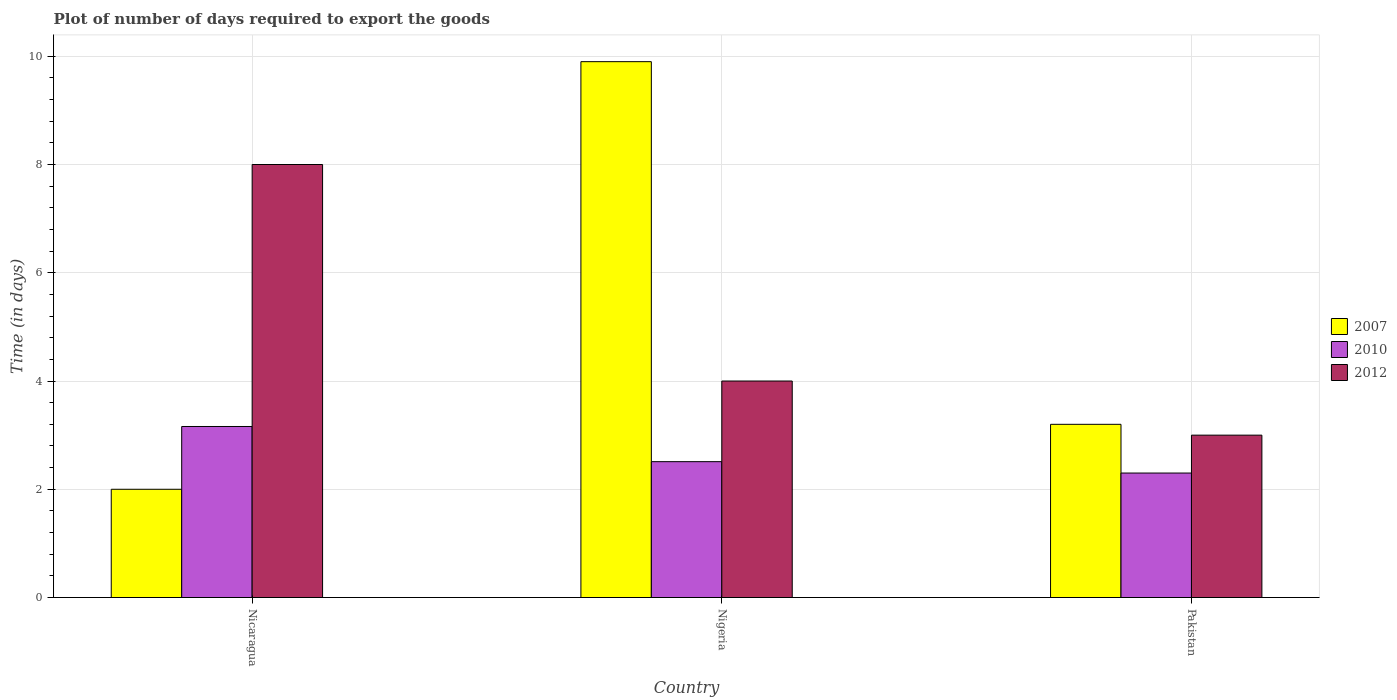Are the number of bars per tick equal to the number of legend labels?
Your response must be concise. Yes. How many bars are there on the 2nd tick from the left?
Keep it short and to the point. 3. What is the time required to export goods in 2010 in Pakistan?
Provide a succinct answer. 2.3. In which country was the time required to export goods in 2007 maximum?
Offer a terse response. Nigeria. What is the difference between the time required to export goods in 2010 in Nigeria and that in Pakistan?
Offer a very short reply. 0.21. What is the difference between the time required to export goods in 2012 in Nigeria and the time required to export goods in 2010 in Nicaragua?
Provide a succinct answer. 0.84. In how many countries, is the time required to export goods in 2012 greater than 7.6 days?
Provide a short and direct response. 1. Is the time required to export goods in 2012 in Nicaragua less than that in Pakistan?
Give a very brief answer. No. In how many countries, is the time required to export goods in 2010 greater than the average time required to export goods in 2010 taken over all countries?
Your answer should be very brief. 1. What does the 3rd bar from the left in Pakistan represents?
Your answer should be very brief. 2012. How many bars are there?
Your answer should be compact. 9. Are all the bars in the graph horizontal?
Give a very brief answer. No. Are the values on the major ticks of Y-axis written in scientific E-notation?
Your answer should be compact. No. Where does the legend appear in the graph?
Give a very brief answer. Center right. How many legend labels are there?
Offer a very short reply. 3. What is the title of the graph?
Ensure brevity in your answer.  Plot of number of days required to export the goods. Does "1985" appear as one of the legend labels in the graph?
Your answer should be very brief. No. What is the label or title of the Y-axis?
Ensure brevity in your answer.  Time (in days). What is the Time (in days) of 2010 in Nicaragua?
Your answer should be compact. 3.16. What is the Time (in days) in 2007 in Nigeria?
Offer a very short reply. 9.9. What is the Time (in days) in 2010 in Nigeria?
Ensure brevity in your answer.  2.51. What is the Time (in days) in 2012 in Nigeria?
Make the answer very short. 4. What is the Time (in days) in 2007 in Pakistan?
Provide a short and direct response. 3.2. What is the Time (in days) in 2010 in Pakistan?
Make the answer very short. 2.3. Across all countries, what is the maximum Time (in days) of 2010?
Your response must be concise. 3.16. Across all countries, what is the maximum Time (in days) of 2012?
Offer a terse response. 8. Across all countries, what is the minimum Time (in days) in 2010?
Make the answer very short. 2.3. What is the total Time (in days) in 2007 in the graph?
Your answer should be very brief. 15.1. What is the total Time (in days) of 2010 in the graph?
Offer a terse response. 7.97. What is the total Time (in days) of 2012 in the graph?
Your answer should be very brief. 15. What is the difference between the Time (in days) in 2010 in Nicaragua and that in Nigeria?
Offer a very short reply. 0.65. What is the difference between the Time (in days) in 2012 in Nicaragua and that in Nigeria?
Provide a short and direct response. 4. What is the difference between the Time (in days) in 2010 in Nicaragua and that in Pakistan?
Your answer should be very brief. 0.86. What is the difference between the Time (in days) of 2007 in Nigeria and that in Pakistan?
Offer a very short reply. 6.7. What is the difference between the Time (in days) in 2010 in Nigeria and that in Pakistan?
Keep it short and to the point. 0.21. What is the difference between the Time (in days) in 2012 in Nigeria and that in Pakistan?
Offer a very short reply. 1. What is the difference between the Time (in days) of 2007 in Nicaragua and the Time (in days) of 2010 in Nigeria?
Give a very brief answer. -0.51. What is the difference between the Time (in days) of 2007 in Nicaragua and the Time (in days) of 2012 in Nigeria?
Offer a very short reply. -2. What is the difference between the Time (in days) in 2010 in Nicaragua and the Time (in days) in 2012 in Nigeria?
Offer a very short reply. -0.84. What is the difference between the Time (in days) of 2007 in Nicaragua and the Time (in days) of 2010 in Pakistan?
Provide a succinct answer. -0.3. What is the difference between the Time (in days) in 2007 in Nicaragua and the Time (in days) in 2012 in Pakistan?
Make the answer very short. -1. What is the difference between the Time (in days) of 2010 in Nicaragua and the Time (in days) of 2012 in Pakistan?
Provide a succinct answer. 0.16. What is the difference between the Time (in days) in 2010 in Nigeria and the Time (in days) in 2012 in Pakistan?
Your response must be concise. -0.49. What is the average Time (in days) of 2007 per country?
Your answer should be very brief. 5.03. What is the average Time (in days) of 2010 per country?
Give a very brief answer. 2.66. What is the average Time (in days) of 2012 per country?
Your answer should be very brief. 5. What is the difference between the Time (in days) in 2007 and Time (in days) in 2010 in Nicaragua?
Give a very brief answer. -1.16. What is the difference between the Time (in days) of 2010 and Time (in days) of 2012 in Nicaragua?
Provide a short and direct response. -4.84. What is the difference between the Time (in days) of 2007 and Time (in days) of 2010 in Nigeria?
Your response must be concise. 7.39. What is the difference between the Time (in days) in 2007 and Time (in days) in 2012 in Nigeria?
Your response must be concise. 5.9. What is the difference between the Time (in days) of 2010 and Time (in days) of 2012 in Nigeria?
Give a very brief answer. -1.49. What is the difference between the Time (in days) of 2007 and Time (in days) of 2010 in Pakistan?
Your answer should be very brief. 0.9. What is the difference between the Time (in days) in 2010 and Time (in days) in 2012 in Pakistan?
Your answer should be very brief. -0.7. What is the ratio of the Time (in days) in 2007 in Nicaragua to that in Nigeria?
Your response must be concise. 0.2. What is the ratio of the Time (in days) in 2010 in Nicaragua to that in Nigeria?
Your answer should be compact. 1.26. What is the ratio of the Time (in days) in 2012 in Nicaragua to that in Nigeria?
Your answer should be very brief. 2. What is the ratio of the Time (in days) of 2010 in Nicaragua to that in Pakistan?
Keep it short and to the point. 1.37. What is the ratio of the Time (in days) of 2012 in Nicaragua to that in Pakistan?
Make the answer very short. 2.67. What is the ratio of the Time (in days) in 2007 in Nigeria to that in Pakistan?
Keep it short and to the point. 3.09. What is the ratio of the Time (in days) of 2010 in Nigeria to that in Pakistan?
Keep it short and to the point. 1.09. What is the difference between the highest and the second highest Time (in days) in 2010?
Your answer should be very brief. 0.65. What is the difference between the highest and the second highest Time (in days) in 2012?
Your response must be concise. 4. What is the difference between the highest and the lowest Time (in days) in 2007?
Provide a succinct answer. 7.9. What is the difference between the highest and the lowest Time (in days) of 2010?
Give a very brief answer. 0.86. What is the difference between the highest and the lowest Time (in days) of 2012?
Give a very brief answer. 5. 